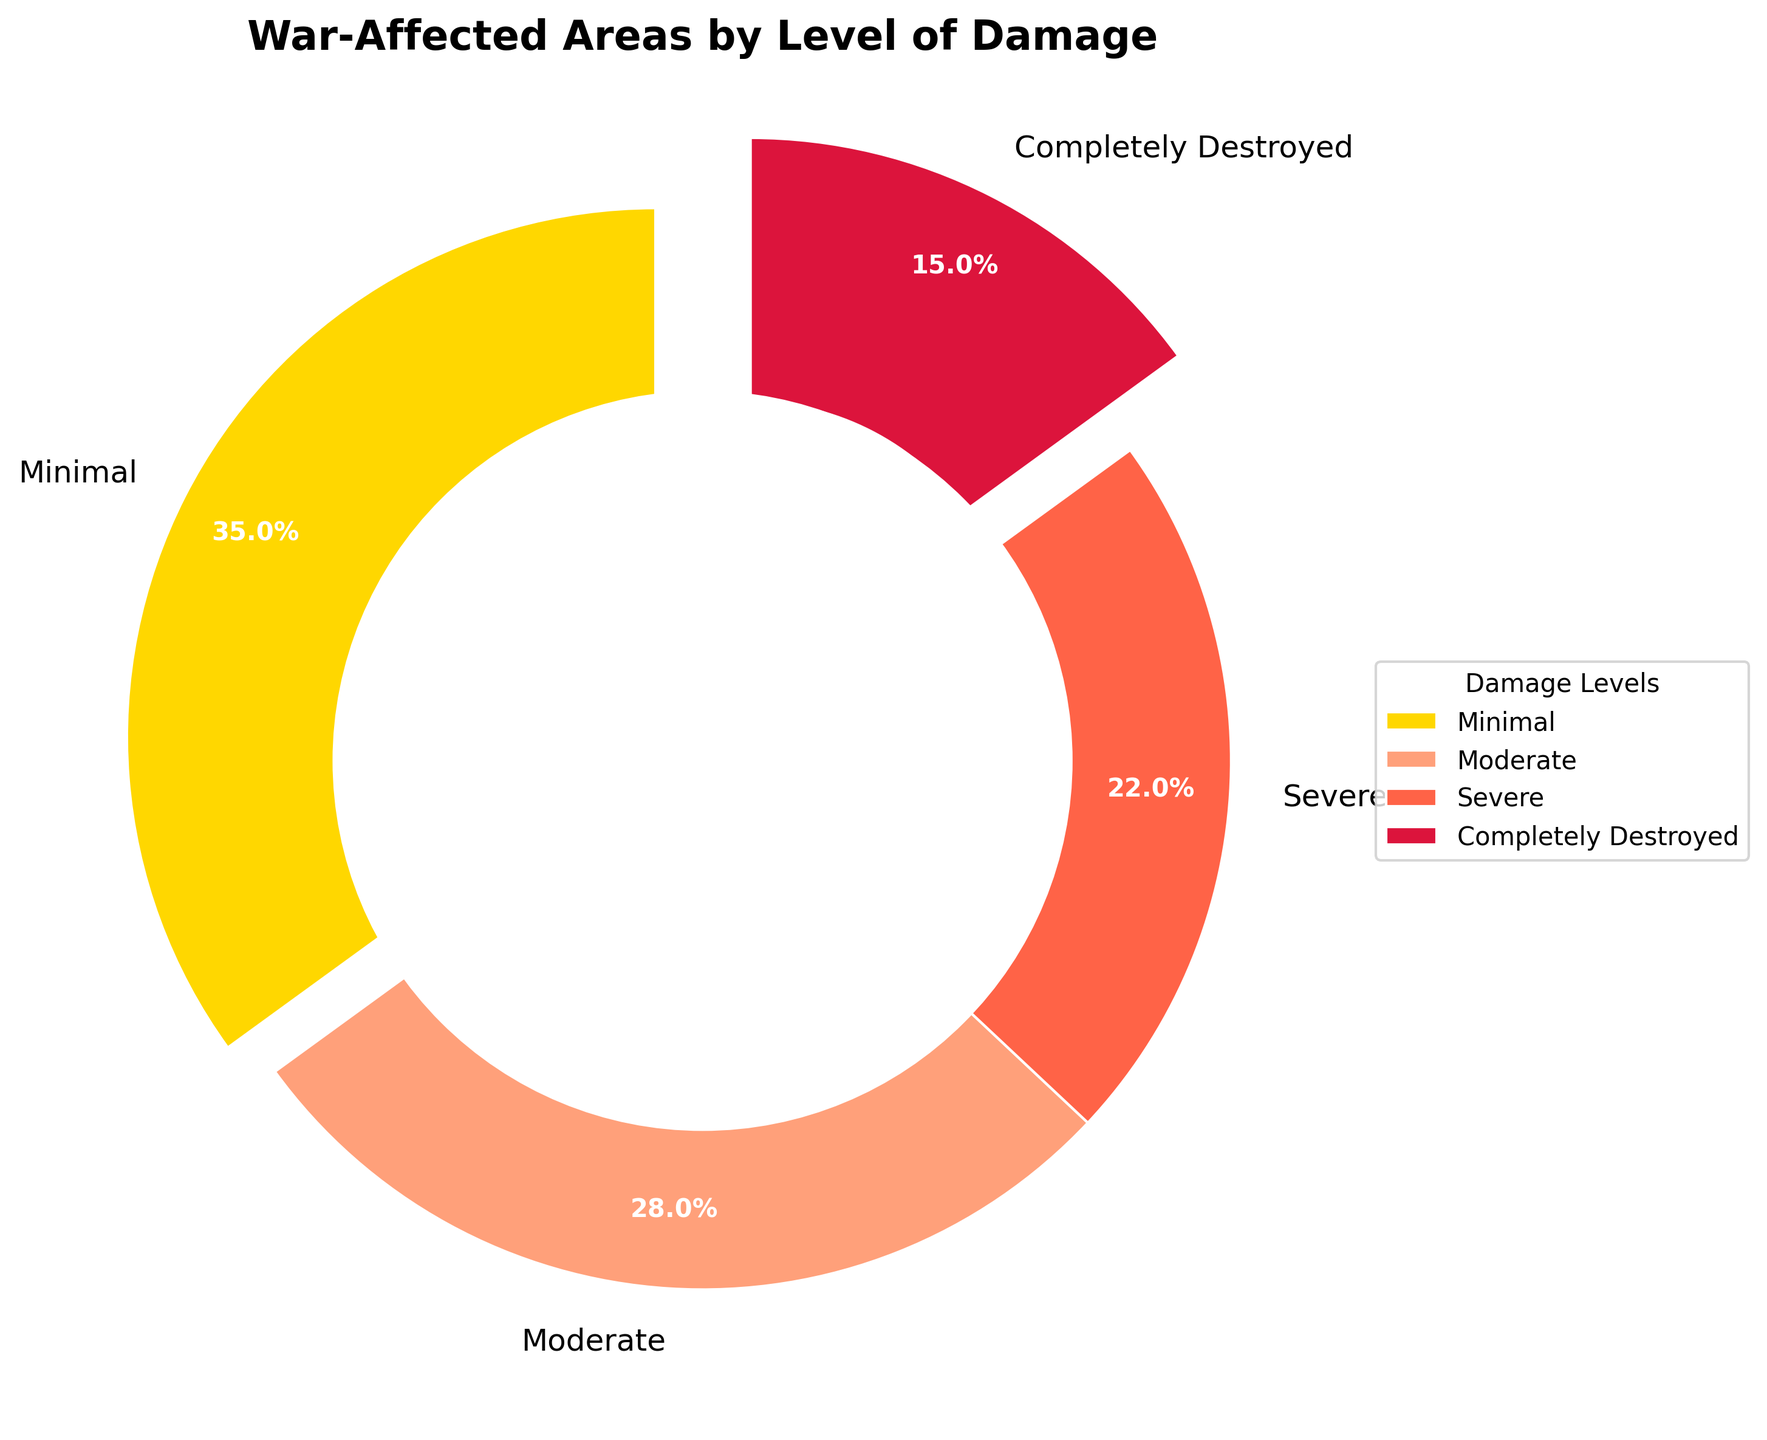What percentage of war-affected areas has severe damage? Refer to the pie chart, look for the section labeled "Severe," then note the percentage displayed.
Answer: 22% Which level of damage has the smallest percentage? Identify the smallest section in the pie chart and read its label.
Answer: Completely Destroyed What is the total percentage of areas affected by minimal and moderate damage combined? Locate the "Minimal" and "Moderate" sections, note the percentages (35% and 28% respectively), and sum them up: 35% + 28% = 63%.
Answer: 63% Which level of damage has the largest section in the pie chart? Observe the pie chart and identify the section that occupies the largest area; the label for this section is "Minimal."
Answer: Minimal Compare the percentages of areas with minimal and completely destroyed damage. Which is higher and by how much? Look at the percentages for "Minimal" and "Completely Destroyed" (35% and 15% respectively), then subtract the smaller from the larger: 35% - 15% = 20%.
Answer: Minimal by 20% If we consider areas with severe and completely destroyed damage together, what percentage do they represent of all war-affected areas? Find the percentages for "Severe" and "Completely Destroyed" (22% and 15%), and sum them: 22% + 15% = 37%.
Answer: 37% What color represents the areas with moderate damage? Identify the section labeled "Moderate" and note its color on the pie chart.
Answer: Light orange Is the section representing minimal damage larger or smaller than the section representing severe damage? Observe the sizes of the "Minimal" and "Severe" sections; "Minimal" is larger.
Answer: Larger What is the difference in percentage between areas with moderate and severe damage? Locate the percentages for "Moderate" and "Severe" (28% and 22%), then find the difference: 28% - 22% = 6%.
Answer: 6% How many different colors are used in the pie chart? Count the different colors representing the sections.
Answer: Four 